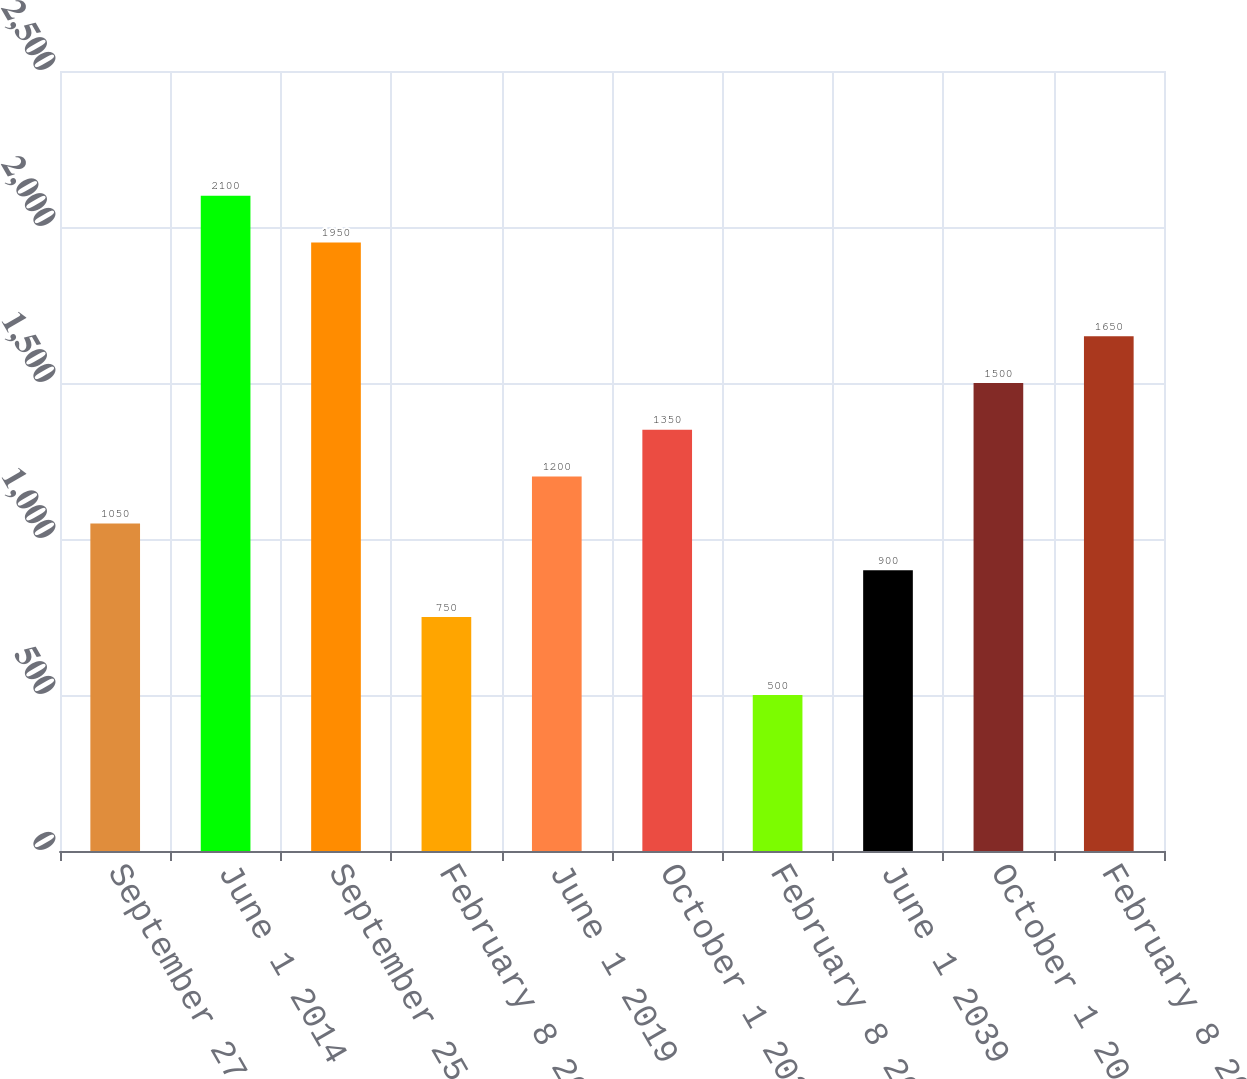Convert chart. <chart><loc_0><loc_0><loc_500><loc_500><bar_chart><fcel>September 27 2013<fcel>June 1 2014<fcel>September 25 2015<fcel>February 8 2016<fcel>June 1 2019<fcel>October 1 2020<fcel>February 8 2021<fcel>June 1 2039<fcel>October 1 2040<fcel>February 8 2041<nl><fcel>1050<fcel>2100<fcel>1950<fcel>750<fcel>1200<fcel>1350<fcel>500<fcel>900<fcel>1500<fcel>1650<nl></chart> 